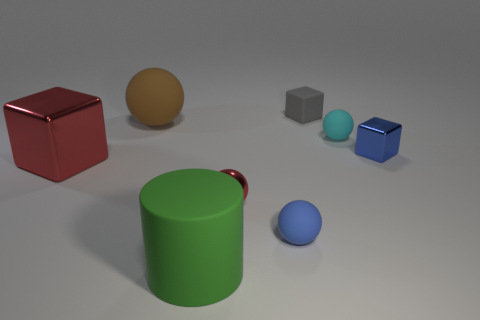Subtract all green blocks. Subtract all red cylinders. How many blocks are left? 3 Subtract all red cylinders. How many blue balls are left? 1 Add 8 grays. How many objects exist? 0 Subtract all large green rubber things. Subtract all big yellow blocks. How many objects are left? 7 Add 5 gray rubber things. How many gray rubber things are left? 6 Add 6 red metallic spheres. How many red metallic spheres exist? 7 Add 1 metallic spheres. How many objects exist? 9 Subtract all red blocks. How many blocks are left? 2 Subtract all metal blocks. How many blocks are left? 1 Subtract 1 red balls. How many objects are left? 7 